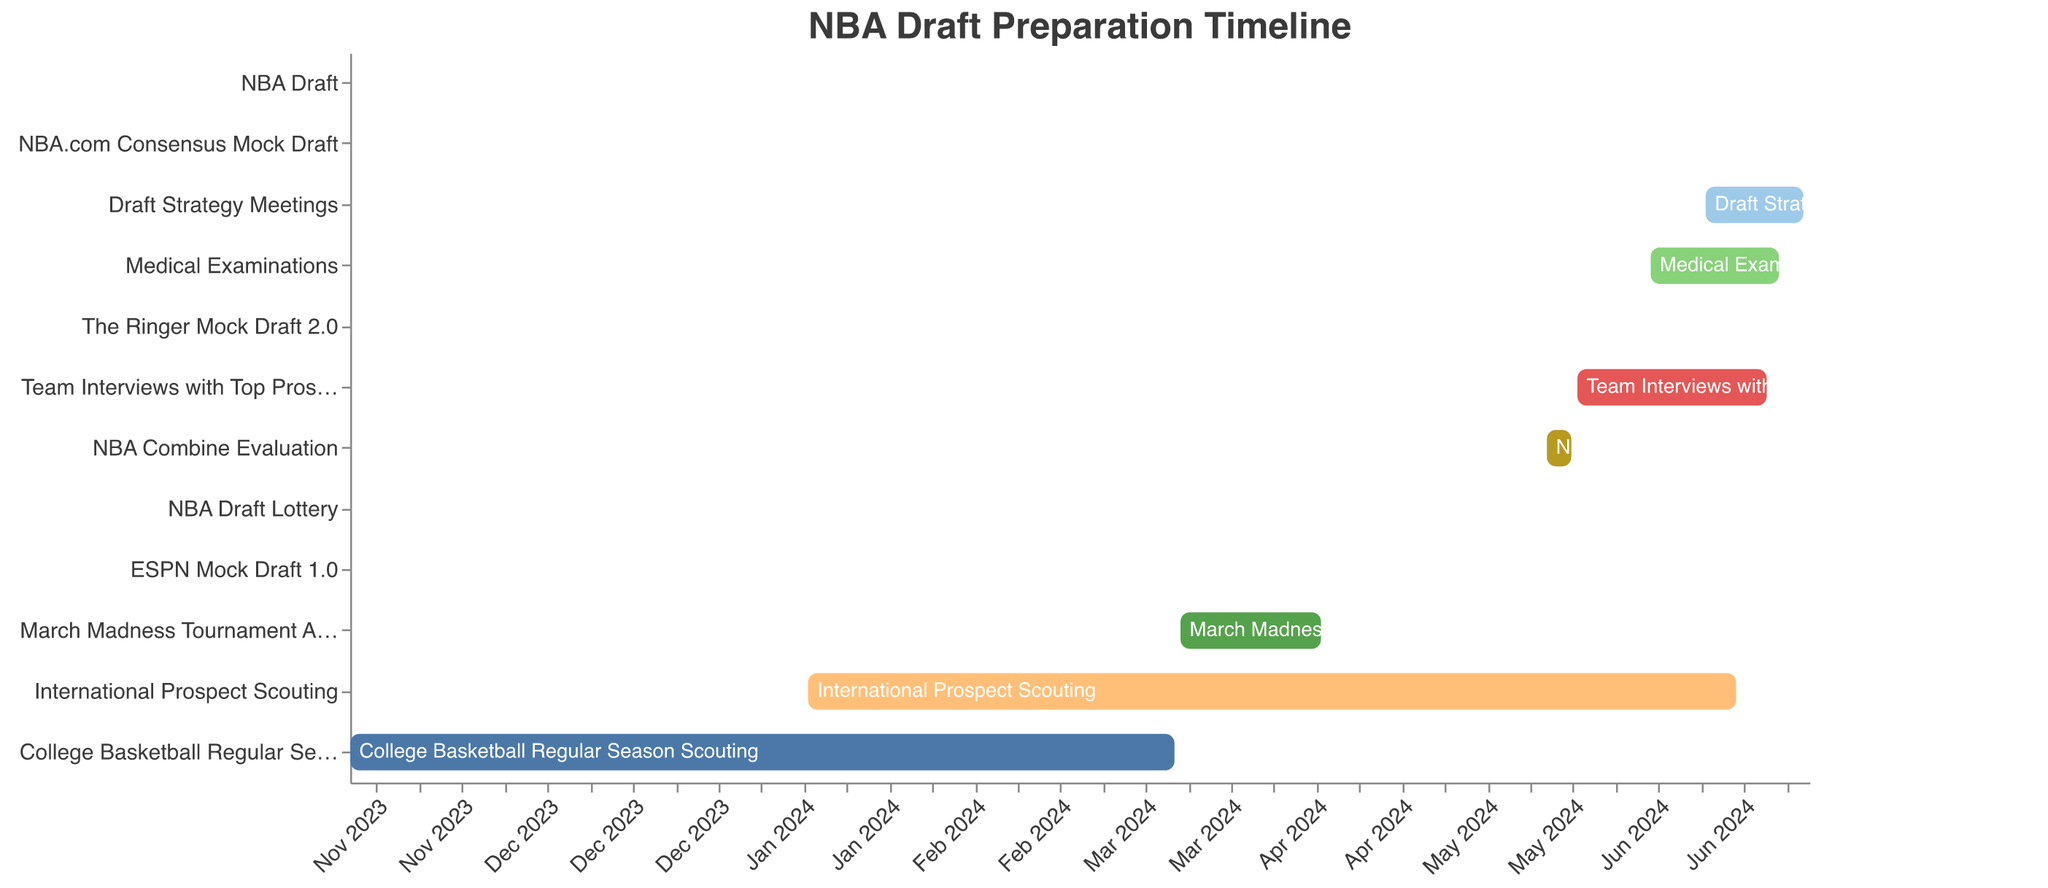What's the title of the figure? The title of the figure is indicated at the top center. It helps to understand the general topic of the figure.
Answer: NBA Draft Preparation Timeline What is the time span for the NBA Combine Evaluation? The Gantt Chart shows the start and end dates for each task. The start date for NBA Combine Evaluation is May 15, 2024, and the end date is May 19, 2024.
Answer: May 15, 2024 to May 19, 2024 Which task starts the earliest in the timeline? By observing the x-axis, we can see the start dates of each task. The earliest start date is for College Basketball Regular Season Scouting, which begins on November 1, 2023.
Answer: College Basketball Regular Season Scouting How long does the March Madness Tournament Analysis last? The start date is March 16, 2024, and the end date is April 8, 2024. To calculate the duration, count the days between the dates, which is 23 days.
Answer: 23 days Which tasks occur entirely within the month of June 2024? By examining the chart, the tasks in June 2024 are Medical Examinations, The Ringer Mock Draft 2.0, NBA.com Consensus Mock Draft, Draft Strategy Meetings, and the NBA Draft. Only The Ringer Mock Draft 2.0 and NBA.com Consensus Mock Draft are completely within June.
Answer: The Ringer Mock Draft 2.0 and NBA.com Consensus Mock Draft Which task has the longest duration? The longest duration can be identified by the length of the bars. International Prospect Scouting spans from January 15, 2024, to June 15, 2024, which is 5 months.
Answer: International Prospect Scouting Does the NBA Combine Evaluation overlap with the NBA Draft Lottery? The NBA Combine Evaluation is from May 15, 2024, to May 19, 2024. The NBA Draft Lottery is on May 14, 2024. Since the Lottery occurs just before the Combine starts, there's no overlap.
Answer: No What tasks are happening when the NBA Combine Evaluation starts? On May 15, 2024, when the NBA Combine Evaluation starts, International Prospect Scouting and ESPN Mock Draft 1.0 are ongoing.
Answer: International Prospect Scouting How many mock drafts are scheduled, and when do they occur? There are three mock draft tasks: ESPN Mock Draft 1.0 (May 1), The Ringer Mock Draft 2.0 (June 1), NBA.com Consensus Mock Draft (June 15).
Answer: 3 mock drafts; May 1, June 1, June 15 Which tasks are scheduled to end the day before the NBA Draft? Checking the day before the NBA Draft (June 26, 2024), the only task ending on this day is Draft Strategy Meetings.
Answer: Draft Strategy Meetings 